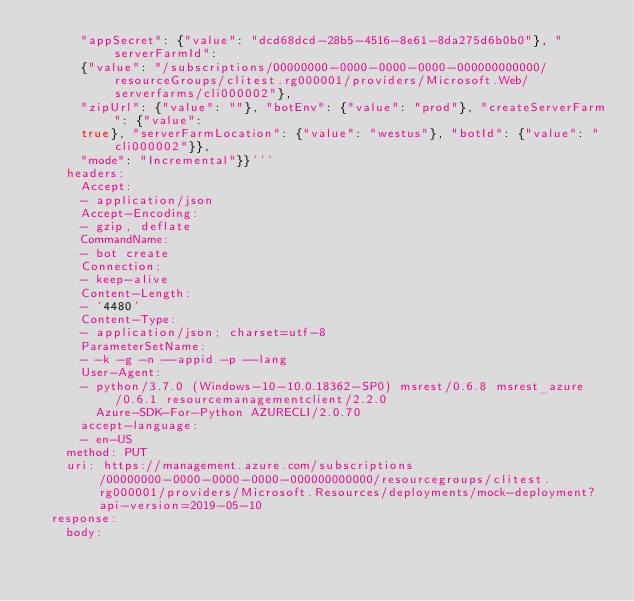Convert code to text. <code><loc_0><loc_0><loc_500><loc_500><_YAML_>      "appSecret": {"value": "dcd68dcd-28b5-4516-8e61-8da275d6b0b0"}, "serverFarmId":
      {"value": "/subscriptions/00000000-0000-0000-0000-000000000000/resourceGroups/clitest.rg000001/providers/Microsoft.Web/serverfarms/cli000002"},
      "zipUrl": {"value": ""}, "botEnv": {"value": "prod"}, "createServerFarm": {"value":
      true}, "serverFarmLocation": {"value": "westus"}, "botId": {"value": "cli000002"}},
      "mode": "Incremental"}}'''
    headers:
      Accept:
      - application/json
      Accept-Encoding:
      - gzip, deflate
      CommandName:
      - bot create
      Connection:
      - keep-alive
      Content-Length:
      - '4480'
      Content-Type:
      - application/json; charset=utf-8
      ParameterSetName:
      - -k -g -n --appid -p --lang
      User-Agent:
      - python/3.7.0 (Windows-10-10.0.18362-SP0) msrest/0.6.8 msrest_azure/0.6.1 resourcemanagementclient/2.2.0
        Azure-SDK-For-Python AZURECLI/2.0.70
      accept-language:
      - en-US
    method: PUT
    uri: https://management.azure.com/subscriptions/00000000-0000-0000-0000-000000000000/resourcegroups/clitest.rg000001/providers/Microsoft.Resources/deployments/mock-deployment?api-version=2019-05-10
  response:
    body:</code> 